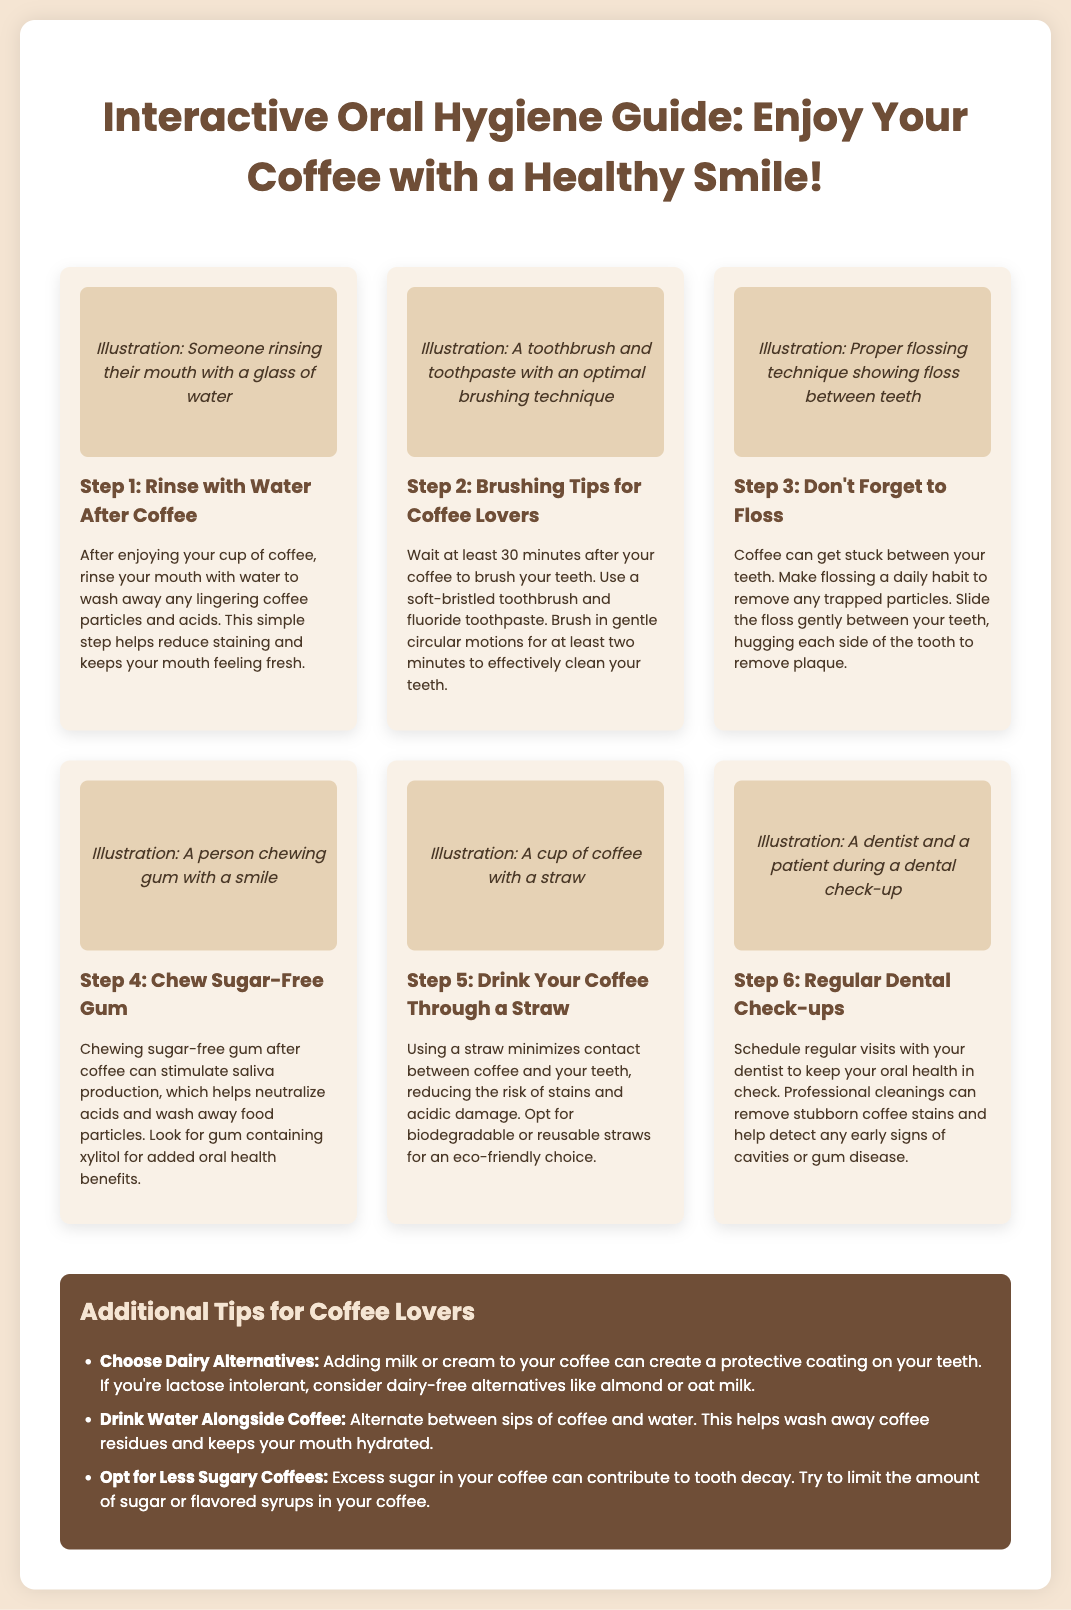What is the title of the guide? The title of the guide is prominently displayed at the top of the document, summarizing its purpose.
Answer: Interactive Oral Hygiene Guide: Enjoy Your Coffee with a Healthy Smile! What is the first step in maintaining oral hygiene after drinking coffee? The first step is mentioned in the section that discusses the immediate actions after coffee consumption.
Answer: Rinse with Water After Coffee How long should you wait to brush your teeth after having coffee? The guide specifies this waiting time in the brushing tips section.
Answer: 30 minutes What should you use for brushing your teeth? This is detailed in the brushing tips section where specific recommendations are provided.
Answer: Soft-bristled toothbrush and fluoride toothpaste What is a benefit of chewing sugar-free gum? The guide explains the benefits in the section about chewing gum after coffee.
Answer: Stimulate saliva production Why is it recommended to drink coffee through a straw? This reasoning is found in the section discussing the effects of coffee on teeth.
Answer: Minimize contact with teeth What professional service is suggested for maintaining oral health? This is mentioned in the section about regular dental check-ups.
Answer: Dental Check-ups Which type of milk is suggested for coffee to create a protective coating? The guide lists dairy alternatives in the tips section for coffee lovers.
Answer: Dairy Alternatives How many tips for coffee lovers are provided in the document? The tips section mentions the total number of tips available.
Answer: Three 